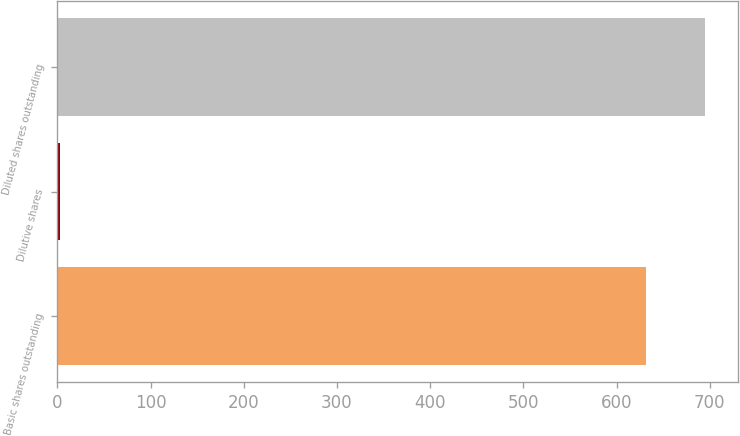Convert chart to OTSL. <chart><loc_0><loc_0><loc_500><loc_500><bar_chart><fcel>Basic shares outstanding<fcel>Dilutive shares<fcel>Diluted shares outstanding<nl><fcel>632<fcel>3.3<fcel>695.2<nl></chart> 